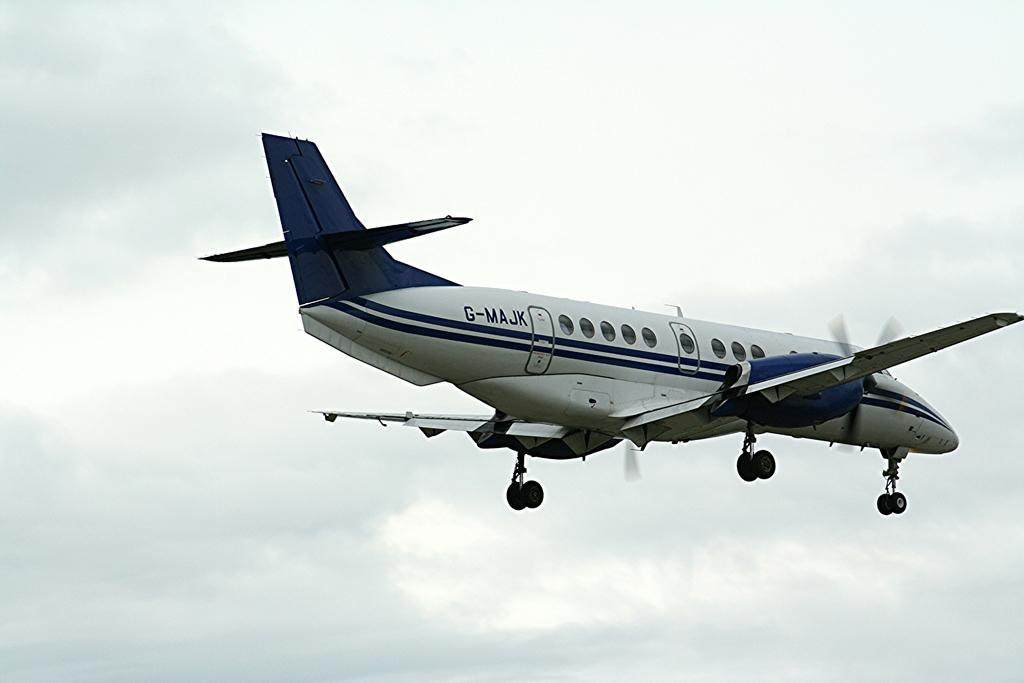<image>
Summarize the visual content of the image. A white and blue plane is flying in the air with the marking G-MAJK near the tail. 